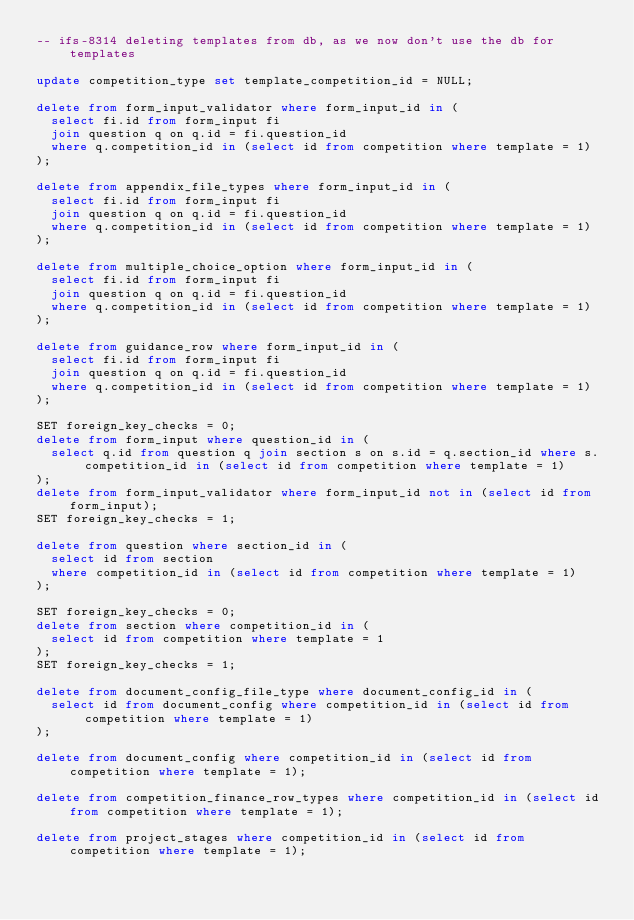<code> <loc_0><loc_0><loc_500><loc_500><_SQL_>-- ifs-8314 deleting templates from db, as we now don't use the db for templates

update competition_type set template_competition_id = NULL;

delete from form_input_validator where form_input_id in (
  select fi.id from form_input fi
  join question q on q.id = fi.question_id
  where q.competition_id in (select id from competition where template = 1)
);

delete from appendix_file_types where form_input_id in (
  select fi.id from form_input fi
  join question q on q.id = fi.question_id
  where q.competition_id in (select id from competition where template = 1)
);

delete from multiple_choice_option where form_input_id in (
  select fi.id from form_input fi
  join question q on q.id = fi.question_id
  where q.competition_id in (select id from competition where template = 1)
);

delete from guidance_row where form_input_id in (
  select fi.id from form_input fi
  join question q on q.id = fi.question_id
  where q.competition_id in (select id from competition where template = 1)
);

SET foreign_key_checks = 0;
delete from form_input where question_id in (
  select q.id from question q join section s on s.id = q.section_id where s.competition_id in (select id from competition where template = 1)
);
delete from form_input_validator where form_input_id not in (select id from form_input);
SET foreign_key_checks = 1;

delete from question where section_id in (
  select id from section
  where competition_id in (select id from competition where template = 1)
);

SET foreign_key_checks = 0;
delete from section where competition_id in (
  select id from competition where template = 1
);
SET foreign_key_checks = 1;

delete from document_config_file_type where document_config_id in (
  select id from document_config where competition_id in (select id from competition where template = 1)
);

delete from document_config where competition_id in (select id from competition where template = 1);

delete from competition_finance_row_types where competition_id in (select id from competition where template = 1);

delete from project_stages where competition_id in (select id from competition where template = 1);
</code> 